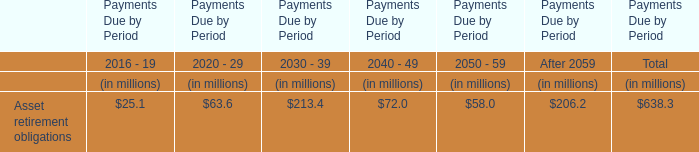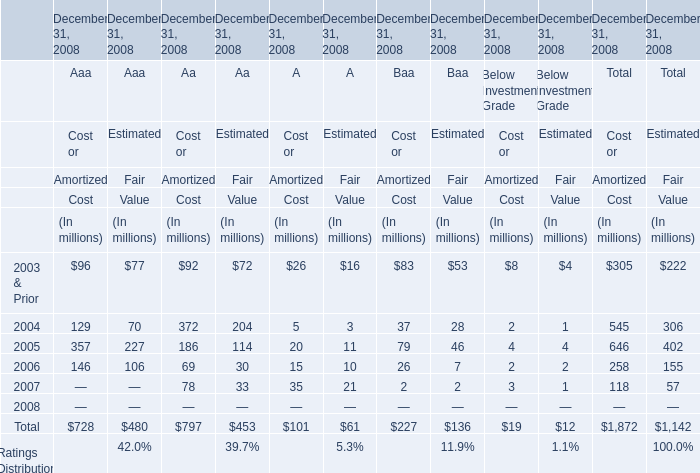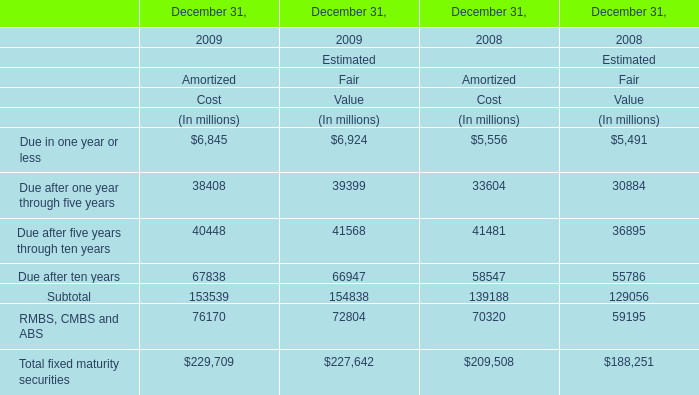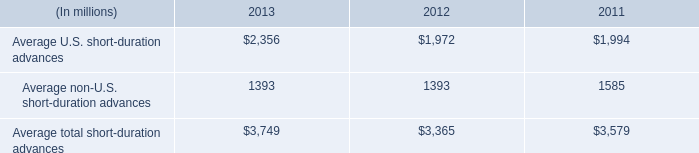What is the highest amount of Amortized Cost in 2009? (in million) 
Answer: 229709. 